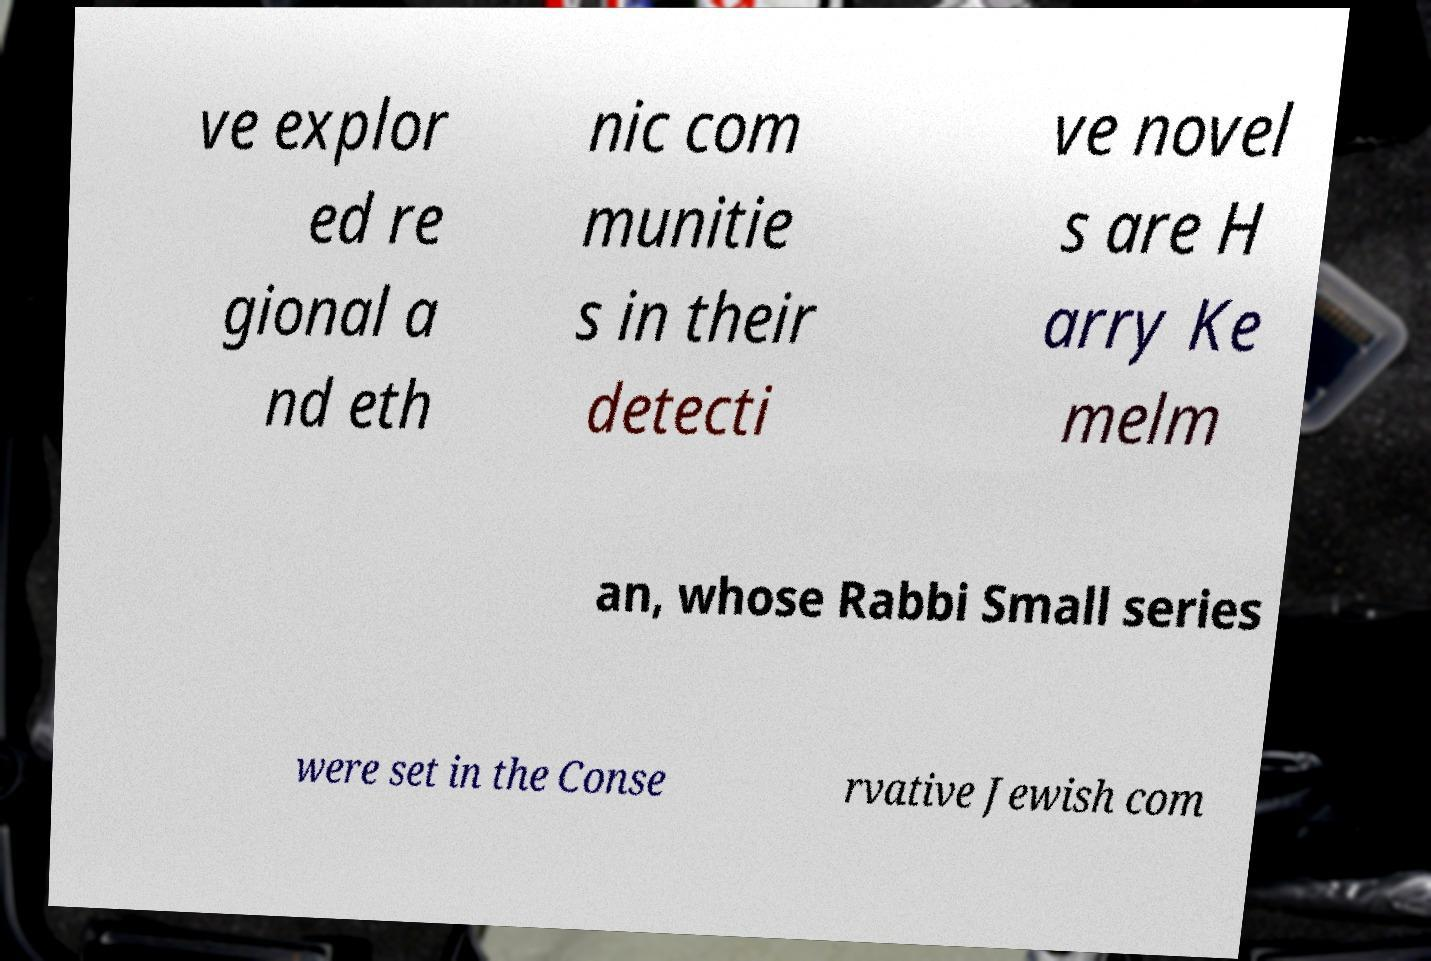Please read and relay the text visible in this image. What does it say? ve explor ed re gional a nd eth nic com munitie s in their detecti ve novel s are H arry Ke melm an, whose Rabbi Small series were set in the Conse rvative Jewish com 